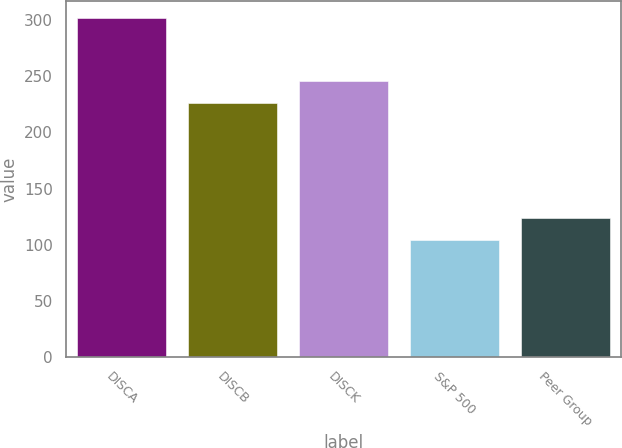Convert chart to OTSL. <chart><loc_0><loc_0><loc_500><loc_500><bar_chart><fcel>DISCA<fcel>DISCB<fcel>DISCK<fcel>S&P 500<fcel>Peer Group<nl><fcel>301.96<fcel>225.95<fcel>245.72<fcel>104.24<fcel>124.01<nl></chart> 